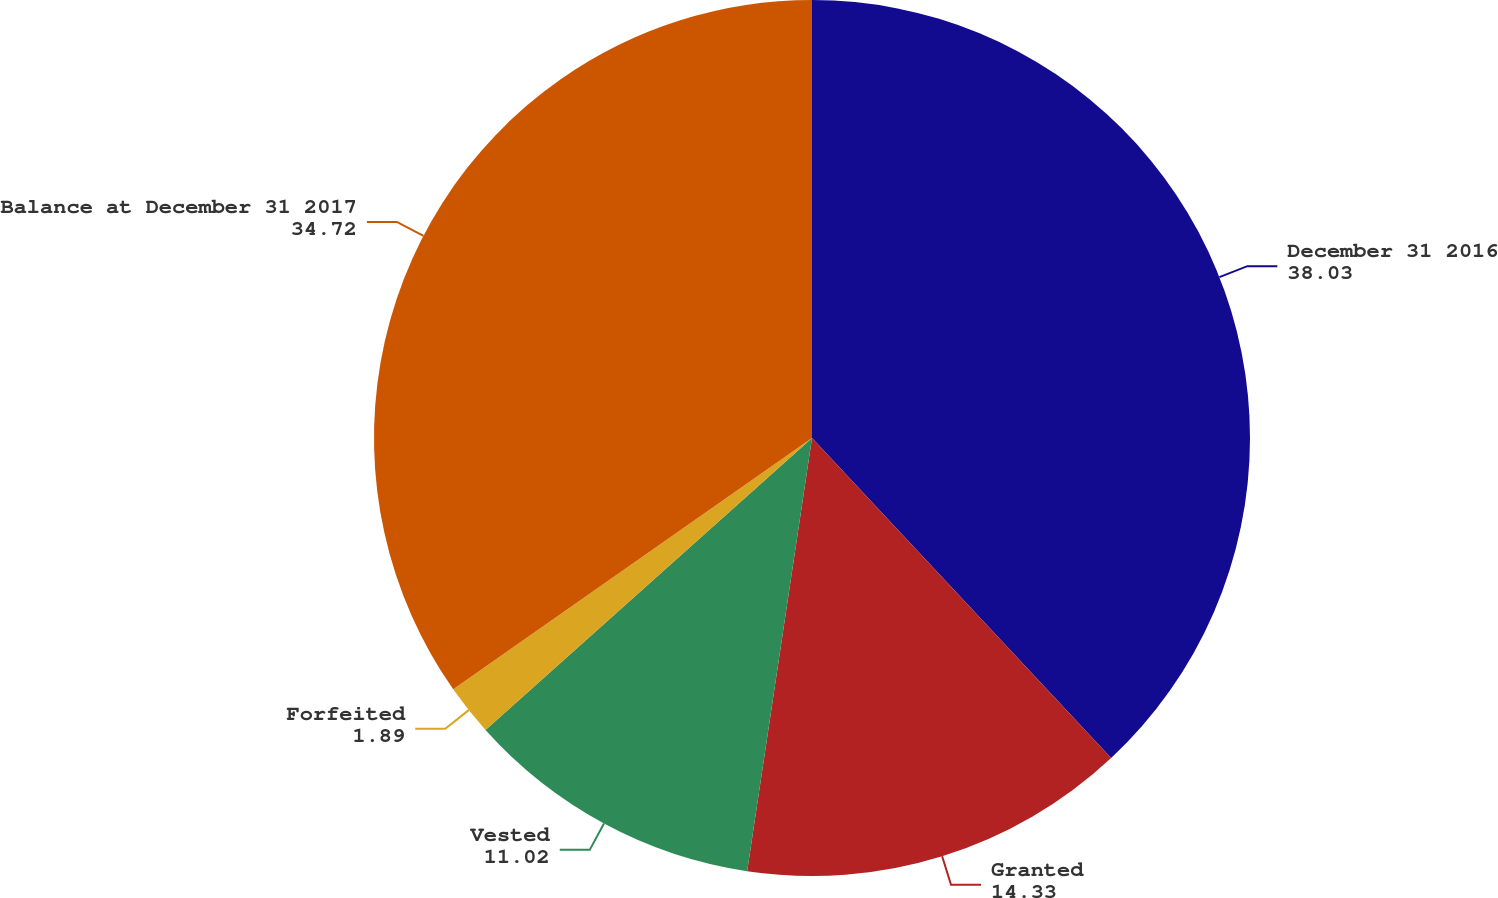Convert chart. <chart><loc_0><loc_0><loc_500><loc_500><pie_chart><fcel>December 31 2016<fcel>Granted<fcel>Vested<fcel>Forfeited<fcel>Balance at December 31 2017<nl><fcel>38.03%<fcel>14.33%<fcel>11.02%<fcel>1.89%<fcel>34.72%<nl></chart> 